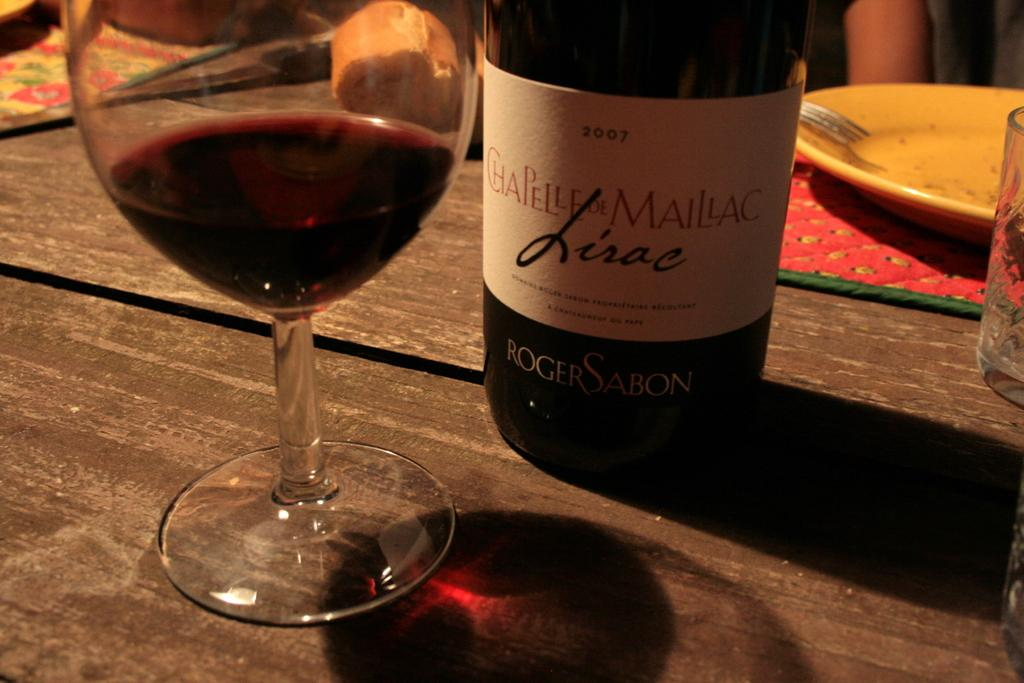<image>
Render a clear and concise summary of the photo. a bottle of wine made in 2007 sits on a table 